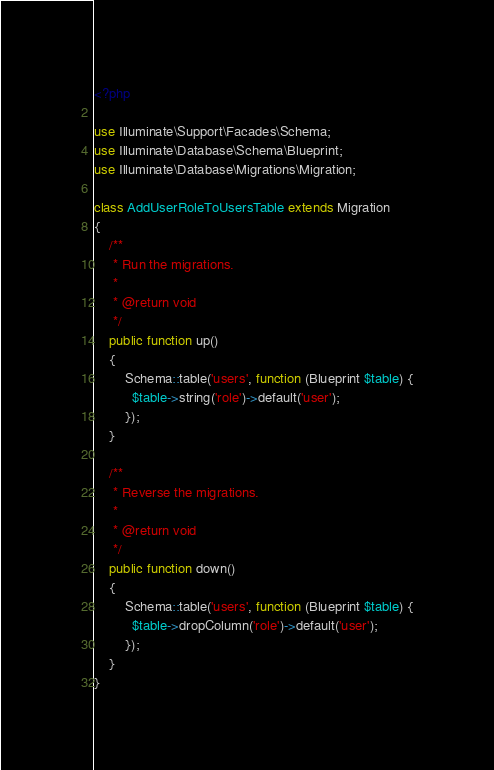Convert code to text. <code><loc_0><loc_0><loc_500><loc_500><_PHP_><?php

use Illuminate\Support\Facades\Schema;
use Illuminate\Database\Schema\Blueprint;
use Illuminate\Database\Migrations\Migration;

class AddUserRoleToUsersTable extends Migration
{
    /**
     * Run the migrations.
     *
     * @return void
     */
    public function up()
    {
        Schema::table('users', function (Blueprint $table) {
          $table->string('role')->default('user');
        });
    }

    /**
     * Reverse the migrations.
     *
     * @return void
     */
    public function down()
    {
        Schema::table('users', function (Blueprint $table) {
          $table->dropColumn('role')->default('user');
        });
    }
}
</code> 